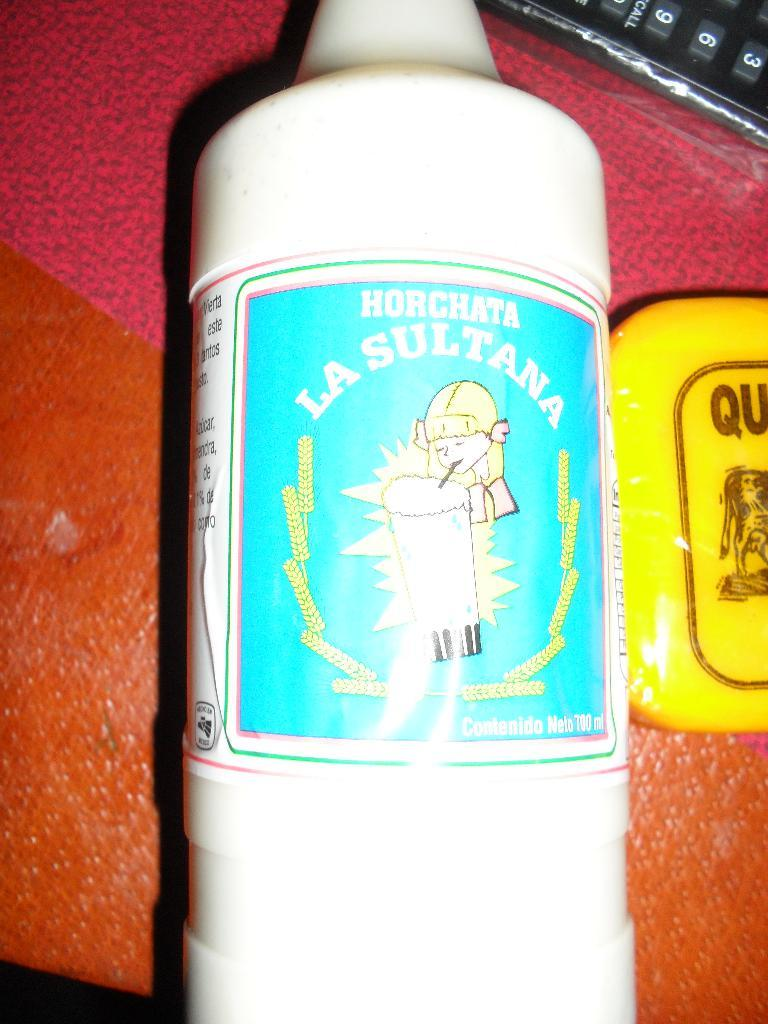<image>
Render a clear and concise summary of the photo. a bottle that has a label that says 'horchata la sultana' 